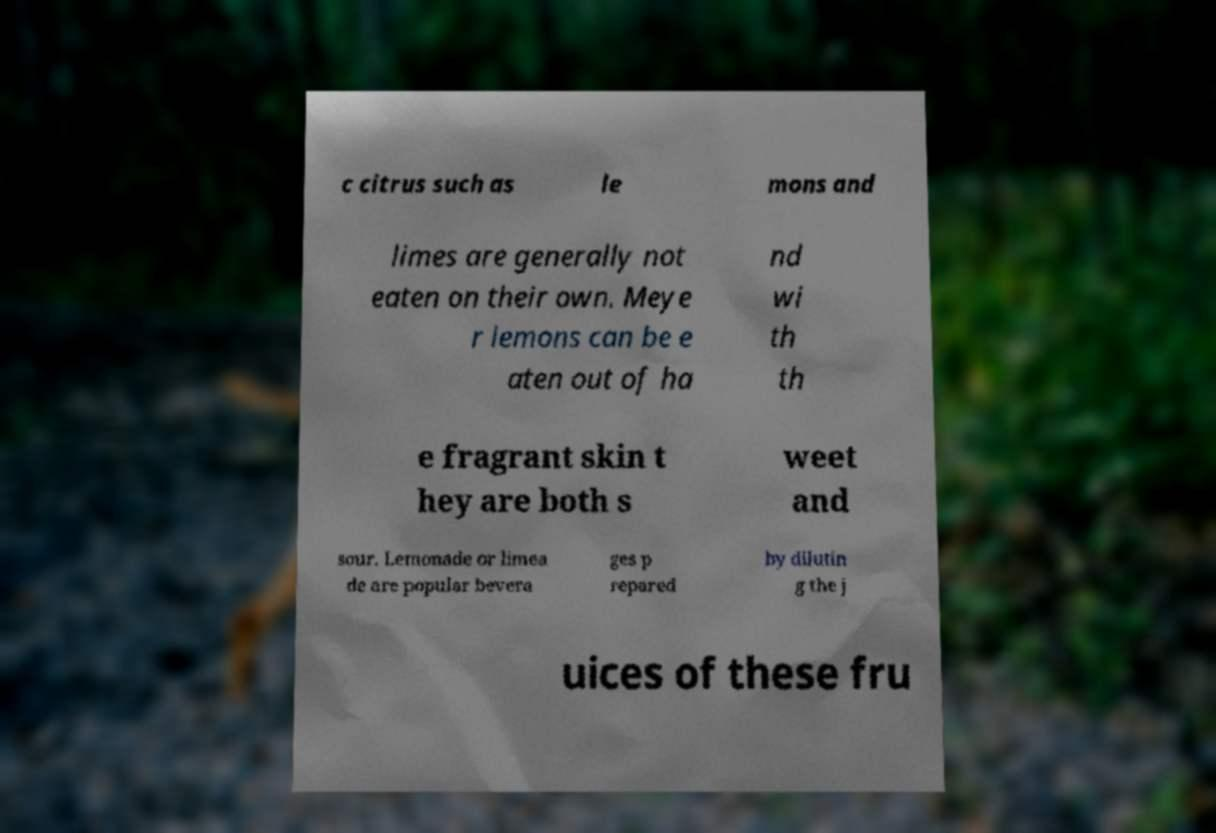Please read and relay the text visible in this image. What does it say? c citrus such as le mons and limes are generally not eaten on their own. Meye r lemons can be e aten out of ha nd wi th th e fragrant skin t hey are both s weet and sour. Lemonade or limea de are popular bevera ges p repared by dilutin g the j uices of these fru 